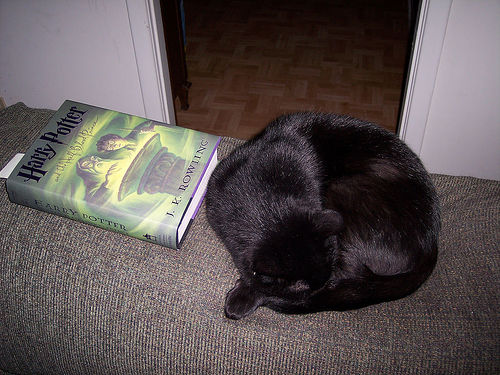<image>
Can you confirm if the cat is on the book? No. The cat is not positioned on the book. They may be near each other, but the cat is not supported by or resting on top of the book. 